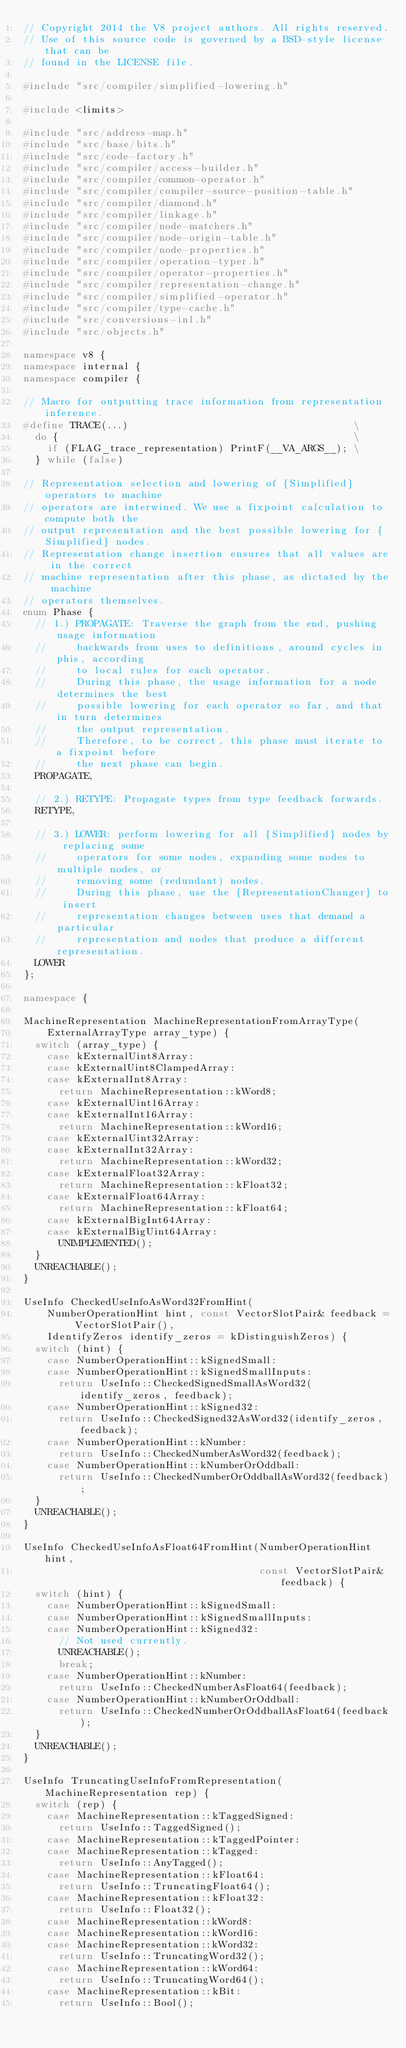Convert code to text. <code><loc_0><loc_0><loc_500><loc_500><_C++_>// Copyright 2014 the V8 project authors. All rights reserved.
// Use of this source code is governed by a BSD-style license that can be
// found in the LICENSE file.

#include "src/compiler/simplified-lowering.h"

#include <limits>

#include "src/address-map.h"
#include "src/base/bits.h"
#include "src/code-factory.h"
#include "src/compiler/access-builder.h"
#include "src/compiler/common-operator.h"
#include "src/compiler/compiler-source-position-table.h"
#include "src/compiler/diamond.h"
#include "src/compiler/linkage.h"
#include "src/compiler/node-matchers.h"
#include "src/compiler/node-origin-table.h"
#include "src/compiler/node-properties.h"
#include "src/compiler/operation-typer.h"
#include "src/compiler/operator-properties.h"
#include "src/compiler/representation-change.h"
#include "src/compiler/simplified-operator.h"
#include "src/compiler/type-cache.h"
#include "src/conversions-inl.h"
#include "src/objects.h"

namespace v8 {
namespace internal {
namespace compiler {

// Macro for outputting trace information from representation inference.
#define TRACE(...)                                      \
  do {                                                  \
    if (FLAG_trace_representation) PrintF(__VA_ARGS__); \
  } while (false)

// Representation selection and lowering of {Simplified} operators to machine
// operators are interwined. We use a fixpoint calculation to compute both the
// output representation and the best possible lowering for {Simplified} nodes.
// Representation change insertion ensures that all values are in the correct
// machine representation after this phase, as dictated by the machine
// operators themselves.
enum Phase {
  // 1.) PROPAGATE: Traverse the graph from the end, pushing usage information
  //     backwards from uses to definitions, around cycles in phis, according
  //     to local rules for each operator.
  //     During this phase, the usage information for a node determines the best
  //     possible lowering for each operator so far, and that in turn determines
  //     the output representation.
  //     Therefore, to be correct, this phase must iterate to a fixpoint before
  //     the next phase can begin.
  PROPAGATE,

  // 2.) RETYPE: Propagate types from type feedback forwards.
  RETYPE,

  // 3.) LOWER: perform lowering for all {Simplified} nodes by replacing some
  //     operators for some nodes, expanding some nodes to multiple nodes, or
  //     removing some (redundant) nodes.
  //     During this phase, use the {RepresentationChanger} to insert
  //     representation changes between uses that demand a particular
  //     representation and nodes that produce a different representation.
  LOWER
};

namespace {

MachineRepresentation MachineRepresentationFromArrayType(
    ExternalArrayType array_type) {
  switch (array_type) {
    case kExternalUint8Array:
    case kExternalUint8ClampedArray:
    case kExternalInt8Array:
      return MachineRepresentation::kWord8;
    case kExternalUint16Array:
    case kExternalInt16Array:
      return MachineRepresentation::kWord16;
    case kExternalUint32Array:
    case kExternalInt32Array:
      return MachineRepresentation::kWord32;
    case kExternalFloat32Array:
      return MachineRepresentation::kFloat32;
    case kExternalFloat64Array:
      return MachineRepresentation::kFloat64;
    case kExternalBigInt64Array:
    case kExternalBigUint64Array:
      UNIMPLEMENTED();
  }
  UNREACHABLE();
}

UseInfo CheckedUseInfoAsWord32FromHint(
    NumberOperationHint hint, const VectorSlotPair& feedback = VectorSlotPair(),
    IdentifyZeros identify_zeros = kDistinguishZeros) {
  switch (hint) {
    case NumberOperationHint::kSignedSmall:
    case NumberOperationHint::kSignedSmallInputs:
      return UseInfo::CheckedSignedSmallAsWord32(identify_zeros, feedback);
    case NumberOperationHint::kSigned32:
      return UseInfo::CheckedSigned32AsWord32(identify_zeros, feedback);
    case NumberOperationHint::kNumber:
      return UseInfo::CheckedNumberAsWord32(feedback);
    case NumberOperationHint::kNumberOrOddball:
      return UseInfo::CheckedNumberOrOddballAsWord32(feedback);
  }
  UNREACHABLE();
}

UseInfo CheckedUseInfoAsFloat64FromHint(NumberOperationHint hint,
                                        const VectorSlotPair& feedback) {
  switch (hint) {
    case NumberOperationHint::kSignedSmall:
    case NumberOperationHint::kSignedSmallInputs:
    case NumberOperationHint::kSigned32:
      // Not used currently.
      UNREACHABLE();
      break;
    case NumberOperationHint::kNumber:
      return UseInfo::CheckedNumberAsFloat64(feedback);
    case NumberOperationHint::kNumberOrOddball:
      return UseInfo::CheckedNumberOrOddballAsFloat64(feedback);
  }
  UNREACHABLE();
}

UseInfo TruncatingUseInfoFromRepresentation(MachineRepresentation rep) {
  switch (rep) {
    case MachineRepresentation::kTaggedSigned:
      return UseInfo::TaggedSigned();
    case MachineRepresentation::kTaggedPointer:
    case MachineRepresentation::kTagged:
      return UseInfo::AnyTagged();
    case MachineRepresentation::kFloat64:
      return UseInfo::TruncatingFloat64();
    case MachineRepresentation::kFloat32:
      return UseInfo::Float32();
    case MachineRepresentation::kWord8:
    case MachineRepresentation::kWord16:
    case MachineRepresentation::kWord32:
      return UseInfo::TruncatingWord32();
    case MachineRepresentation::kWord64:
      return UseInfo::TruncatingWord64();
    case MachineRepresentation::kBit:
      return UseInfo::Bool();</code> 